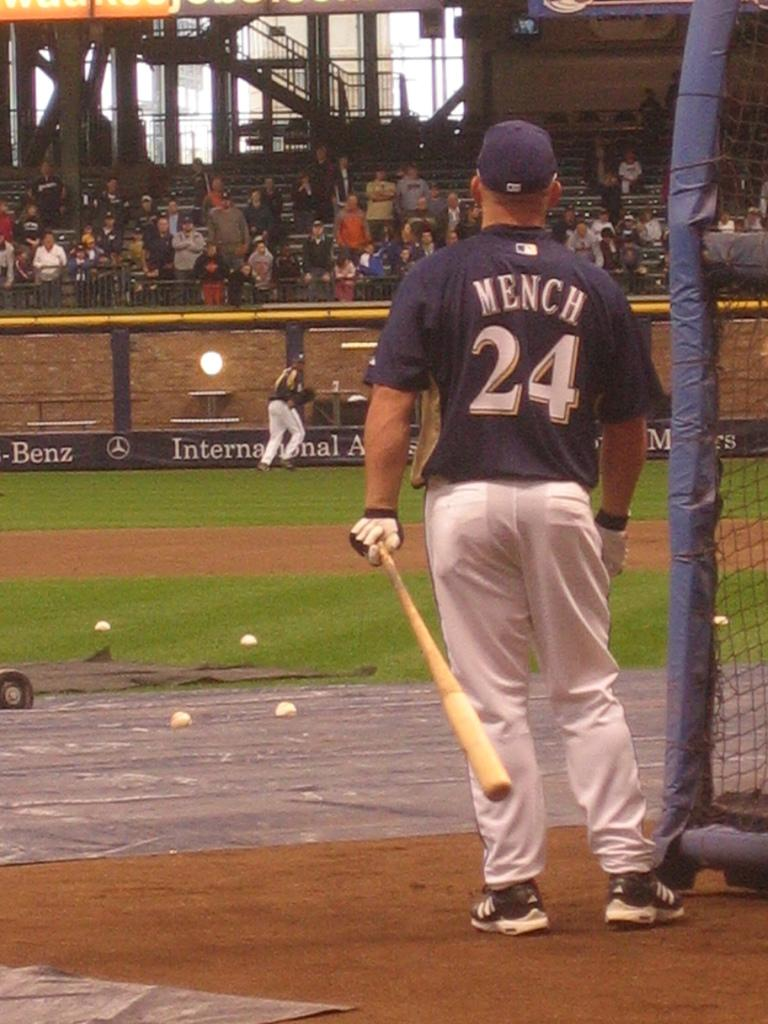<image>
Describe the image concisely. a person with the number 24 on the back of them 